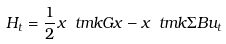Convert formula to latex. <formula><loc_0><loc_0><loc_500><loc_500>H _ { t } = \frac { 1 } { 2 } x \ t m k G x - x \ t m k \Sigma B u _ { t }</formula> 